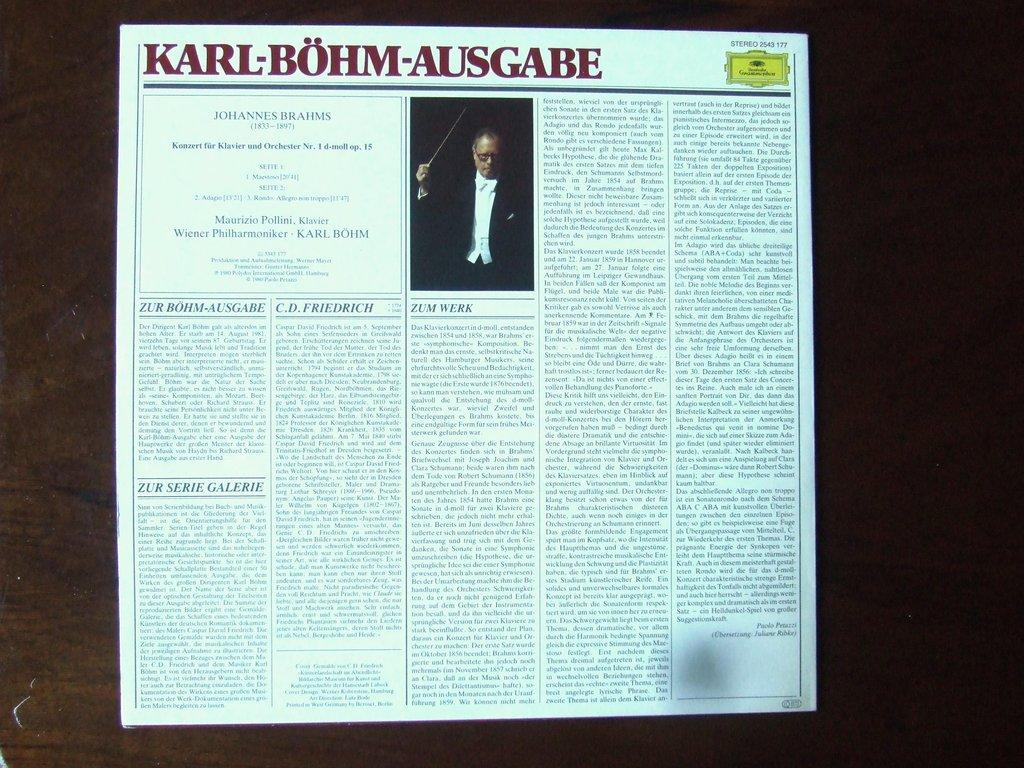Provide a one-sentence caption for the provided image. A written article excerpt from a paper relating to Karl-Bohm-Ausgabe. 